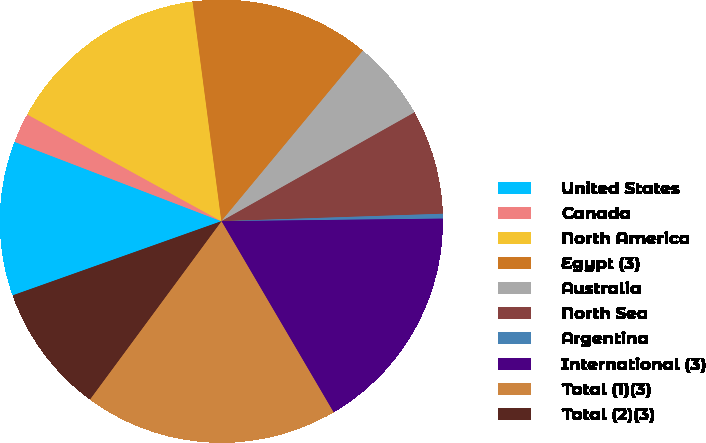Convert chart. <chart><loc_0><loc_0><loc_500><loc_500><pie_chart><fcel>United States<fcel>Canada<fcel>North America<fcel>Egypt (3)<fcel>Australia<fcel>North Sea<fcel>Argentina<fcel>International (3)<fcel>Total (1)(3)<fcel>Total (2)(3)<nl><fcel>11.27%<fcel>2.17%<fcel>14.92%<fcel>13.1%<fcel>5.81%<fcel>7.63%<fcel>0.35%<fcel>16.74%<fcel>18.56%<fcel>9.45%<nl></chart> 